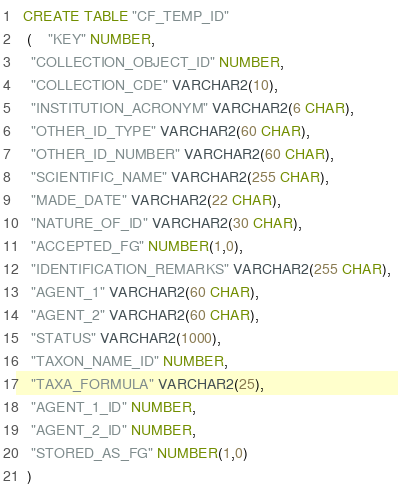<code> <loc_0><loc_0><loc_500><loc_500><_SQL_>
  CREATE TABLE "CF_TEMP_ID" 
   (	"KEY" NUMBER, 
	"COLLECTION_OBJECT_ID" NUMBER, 
	"COLLECTION_CDE" VARCHAR2(10), 
	"INSTITUTION_ACRONYM" VARCHAR2(6 CHAR), 
	"OTHER_ID_TYPE" VARCHAR2(60 CHAR), 
	"OTHER_ID_NUMBER" VARCHAR2(60 CHAR), 
	"SCIENTIFIC_NAME" VARCHAR2(255 CHAR), 
	"MADE_DATE" VARCHAR2(22 CHAR), 
	"NATURE_OF_ID" VARCHAR2(30 CHAR), 
	"ACCEPTED_FG" NUMBER(1,0), 
	"IDENTIFICATION_REMARKS" VARCHAR2(255 CHAR), 
	"AGENT_1" VARCHAR2(60 CHAR), 
	"AGENT_2" VARCHAR2(60 CHAR), 
	"STATUS" VARCHAR2(1000), 
	"TAXON_NAME_ID" NUMBER, 
	"TAXA_FORMULA" VARCHAR2(25), 
	"AGENT_1_ID" NUMBER, 
	"AGENT_2_ID" NUMBER, 
	"STORED_AS_FG" NUMBER(1,0)
   ) </code> 